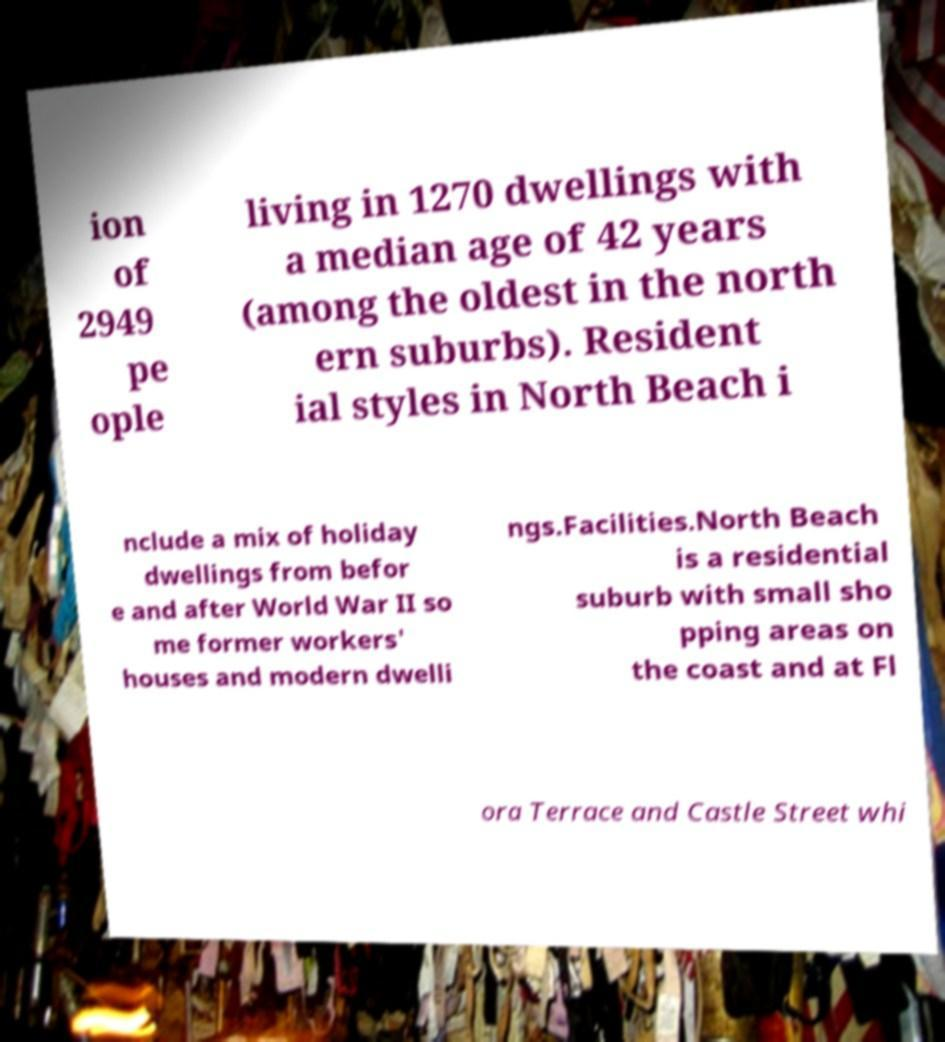I need the written content from this picture converted into text. Can you do that? ion of 2949 pe ople living in 1270 dwellings with a median age of 42 years (among the oldest in the north ern suburbs). Resident ial styles in North Beach i nclude a mix of holiday dwellings from befor e and after World War II so me former workers' houses and modern dwelli ngs.Facilities.North Beach is a residential suburb with small sho pping areas on the coast and at Fl ora Terrace and Castle Street whi 